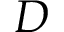Convert formula to latex. <formula><loc_0><loc_0><loc_500><loc_500>D</formula> 